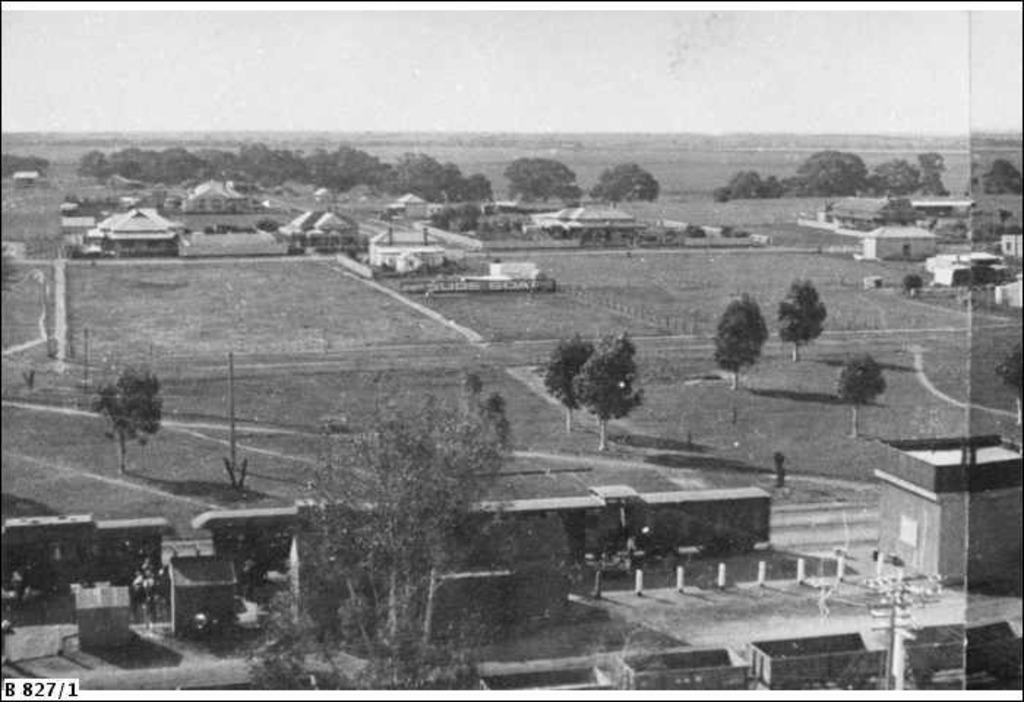What is the color scheme of the image? The image is black and white. What is the main subject of the image? There is a train in the image. What other structures can be seen in the image? There are houses in the image. What type of natural environment is visible in the background? There are trees in the background of the image. What is visible at the top of the image? The sky is visible at the top of the image. How much tax is being paid by the train in the image? There is no indication of tax being paid in the image, as it features a train, houses, trees, and the sky. What emotion is being displayed by the train in the image? The image is black and white and does not depict emotions; it simply shows a train, houses, trees, and the sky. 